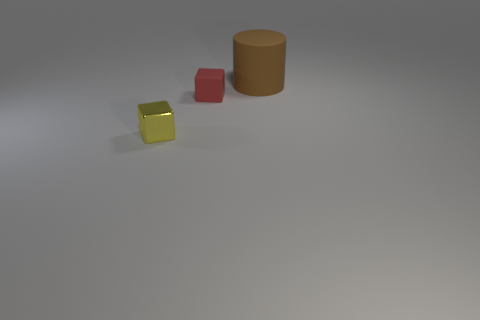Is there anything else that is the same shape as the large brown object?
Ensure brevity in your answer.  No. Are there any other things that are the same size as the matte cylinder?
Ensure brevity in your answer.  No. There is another block that is the same size as the red rubber cube; what is it made of?
Keep it short and to the point. Metal. How many things are tiny objects in front of the small rubber object or things behind the small shiny object?
Provide a short and direct response. 3. There is a brown object that is made of the same material as the red object; what is its size?
Make the answer very short. Large. How many metallic objects are purple cylinders or tiny red cubes?
Your response must be concise. 0. What is the size of the brown cylinder?
Your response must be concise. Large. Is the size of the yellow metal object the same as the red matte block?
Provide a short and direct response. Yes. There is a thing that is on the right side of the small rubber cube; what is it made of?
Offer a terse response. Rubber. There is a small red object that is the same shape as the yellow metal thing; what is its material?
Give a very brief answer. Rubber. 